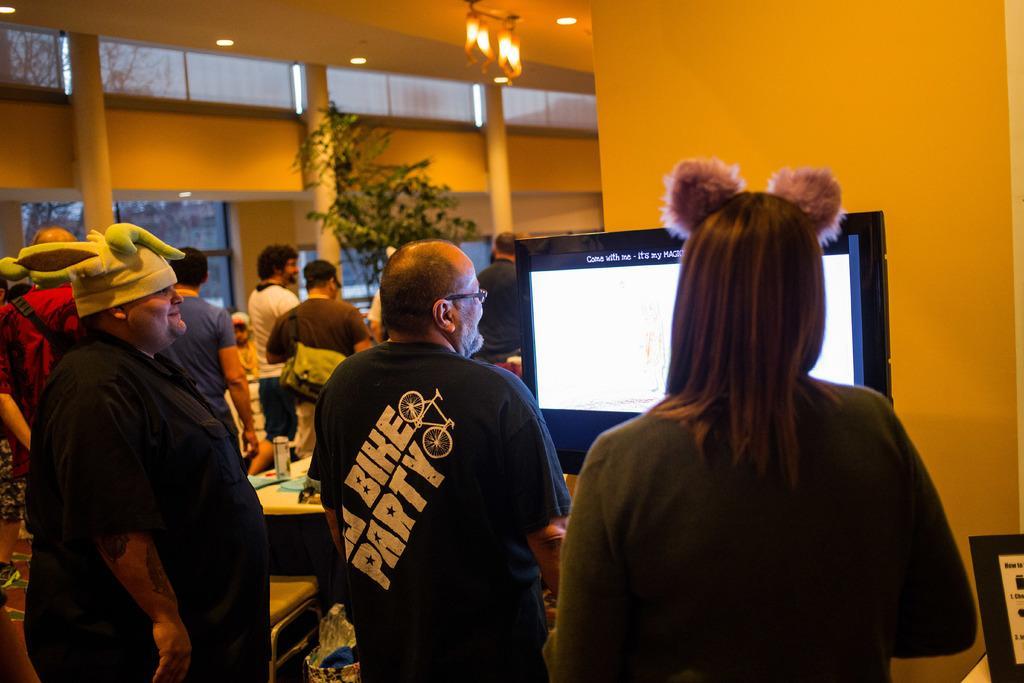Please provide a concise description of this image. Here in this picture we can see number of people standing over a place and in the front we can see a television present on a table and the person on the left side is wearing a cap on him and we can also see a table, on which we can see some tins and papers present and we can see a plant also present and we can see lights present on the roof and through the glass windows we can see trees present outside. 